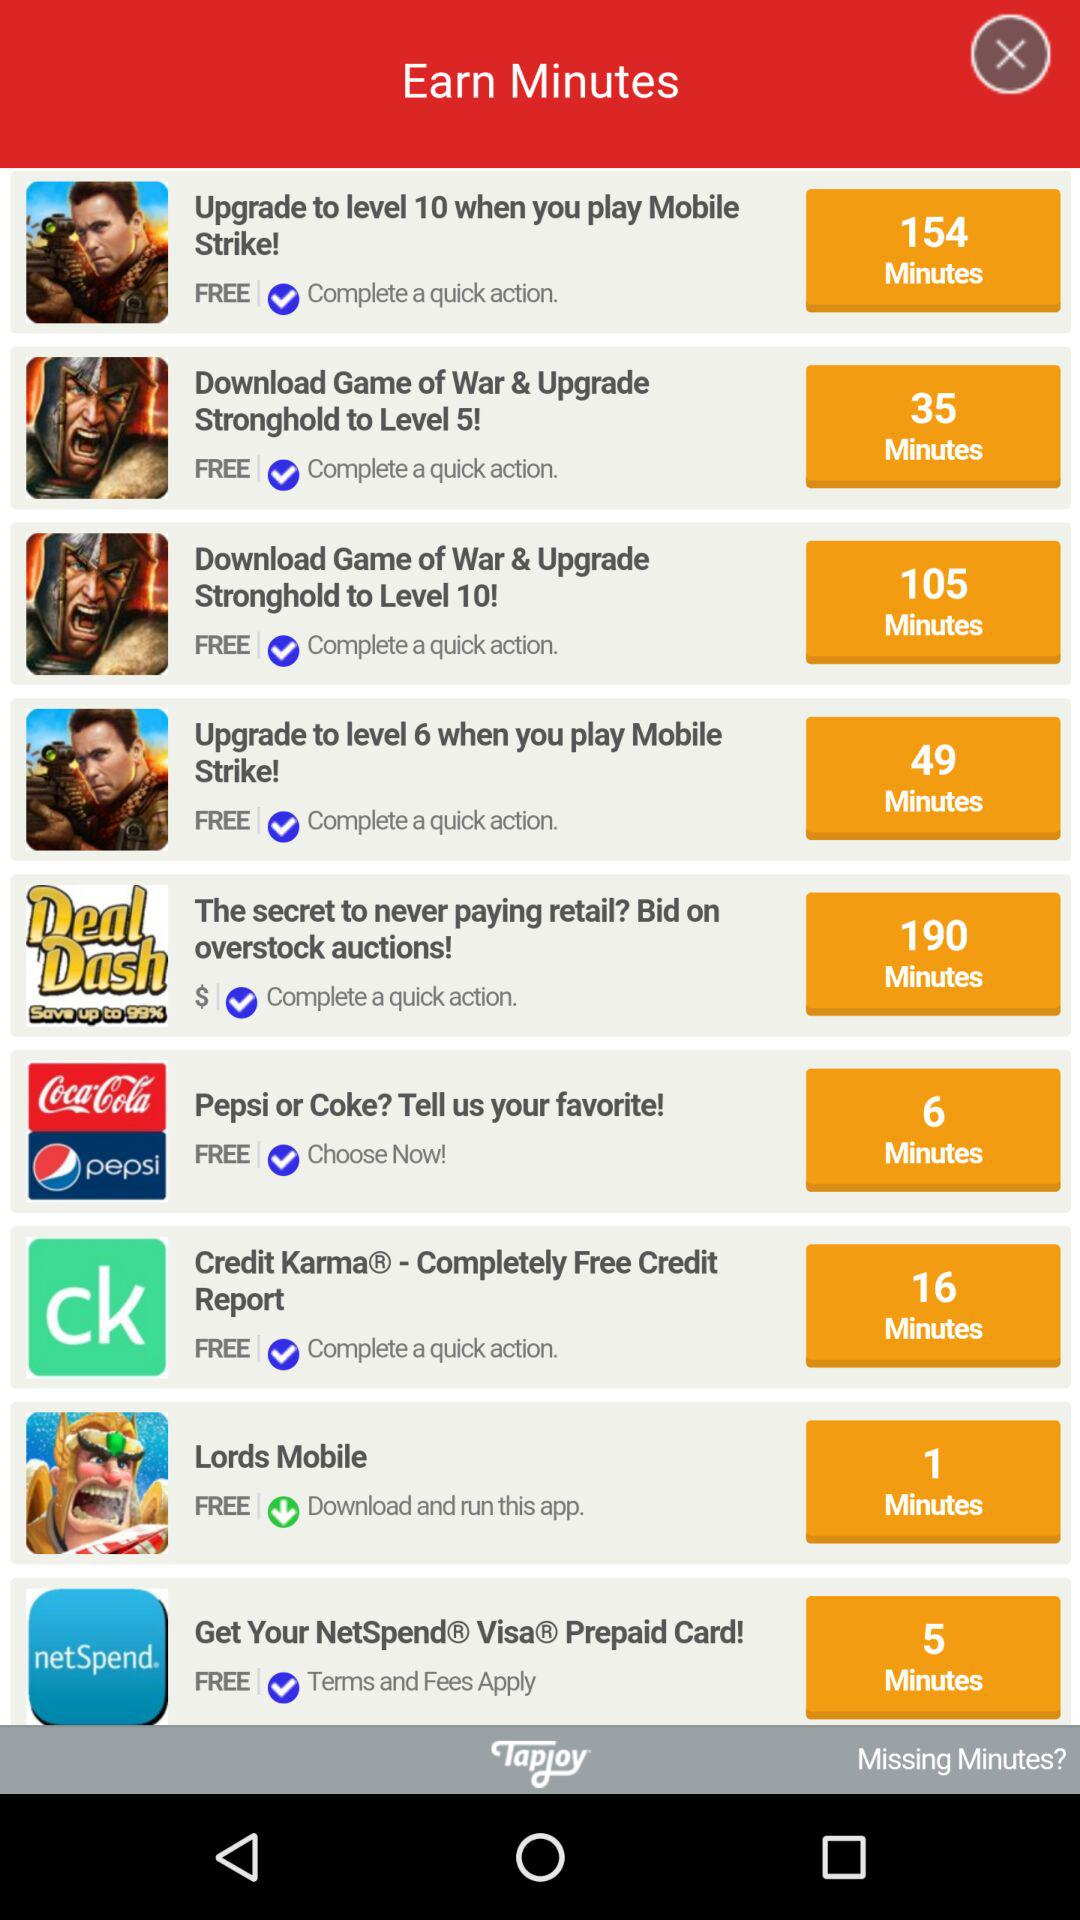By completing which action can 49 minutes be earned? 49 minutes can be earned by completing the action "Upgrade to level 6 when you play Mobile Strike!". 